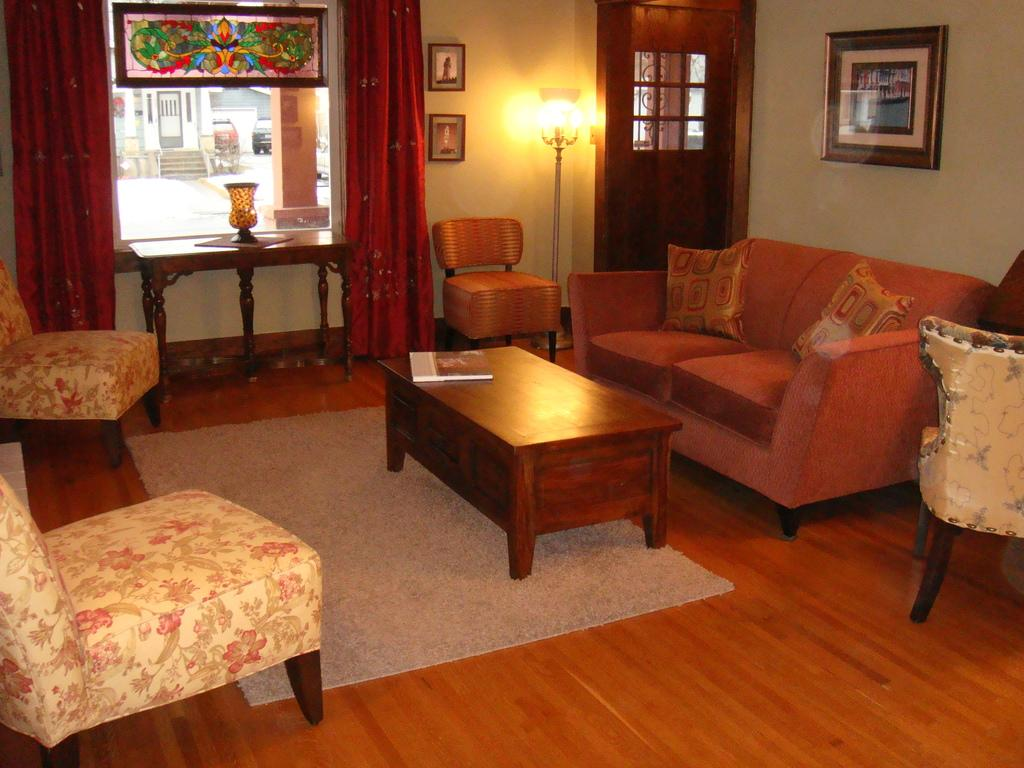What type of furniture is in the image? There is a sofa and chairs on the floor in the image. What other piece of furniture can be seen in the image? There is a table in the image. What type of window treatment is present in the image? There is a curtain in the image. Is there any artwork or decoration on the walls in the image? Yes, there is a photo is on a wall in the image. What type of brick is used to build the sofa in the image? There is no brick used to build the sofa in the image; it is a piece of furniture made of fabric or other materials. 